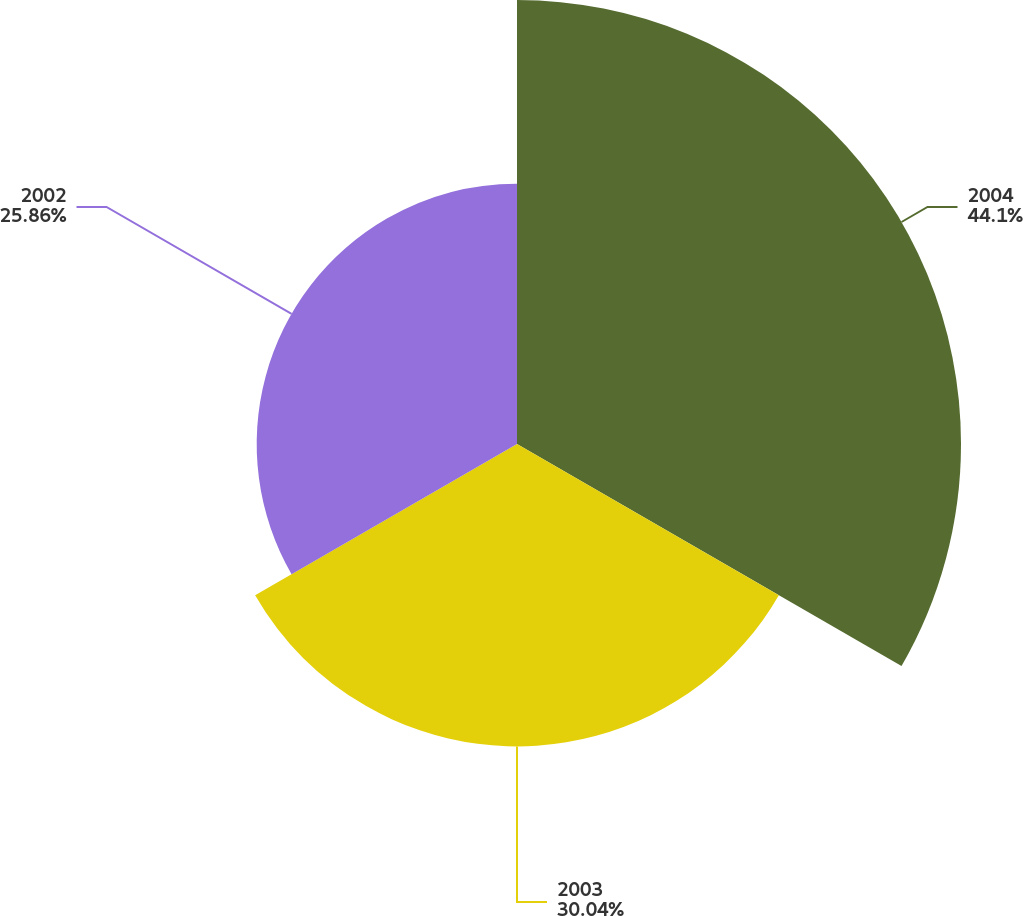<chart> <loc_0><loc_0><loc_500><loc_500><pie_chart><fcel>2004<fcel>2003<fcel>2002<nl><fcel>44.11%<fcel>30.04%<fcel>25.86%<nl></chart> 